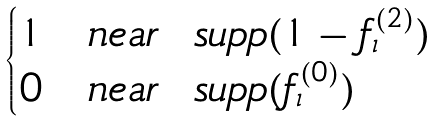Convert formula to latex. <formula><loc_0><loc_0><loc_500><loc_500>\begin{cases} 1 & n e a r \ \ s u p p ( 1 - f _ { \iota } ^ { ( 2 ) } ) \\ 0 & n e a r \ \ s u p p ( f _ { \iota } ^ { ( 0 ) } ) \end{cases}</formula> 